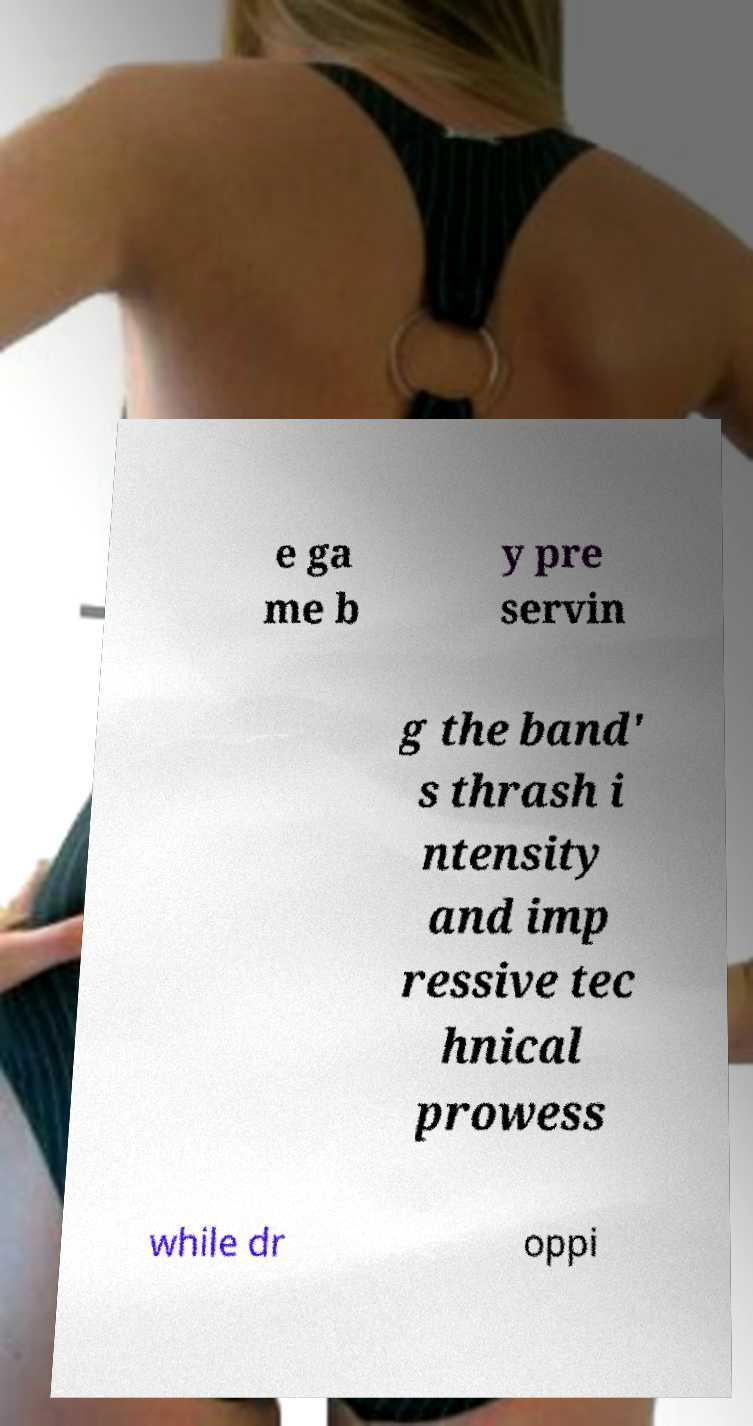For documentation purposes, I need the text within this image transcribed. Could you provide that? e ga me b y pre servin g the band' s thrash i ntensity and imp ressive tec hnical prowess while dr oppi 